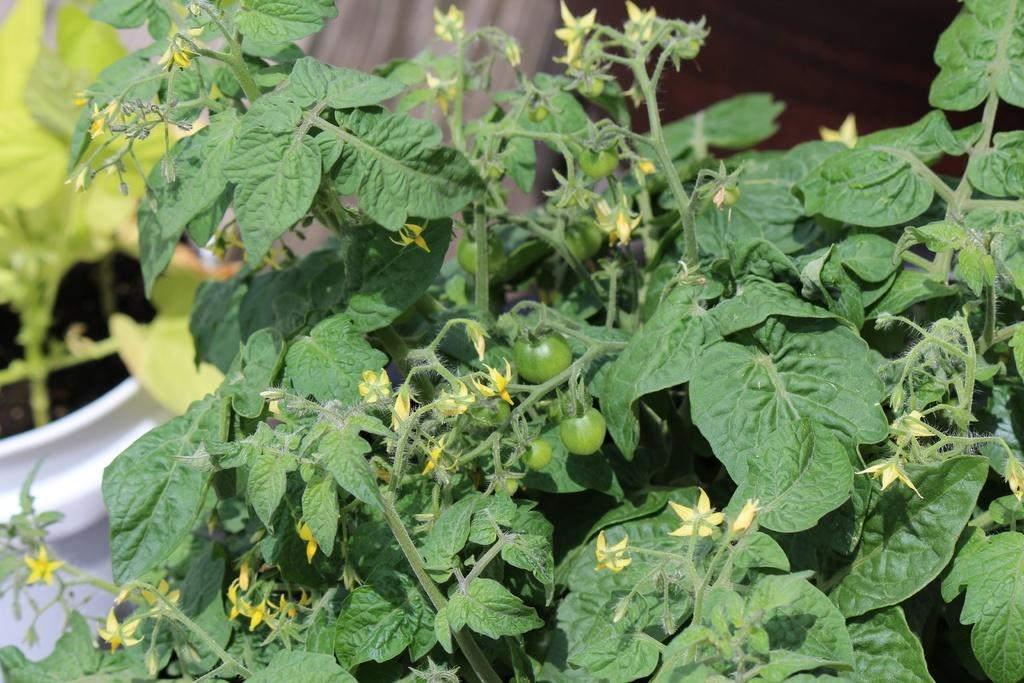What types of living organisms can be seen in the image? Plants, flowers, and vegetables can be seen in the image. Can you describe the flowers in the image? Yes, there are flowers in the image. What type of plants are visible in the image? The plants in the image include vegetables. What type of map can be seen in the image? There is no map present in the image. Is there a note attached to any of the plants in the image? There is no note visible in the image. 